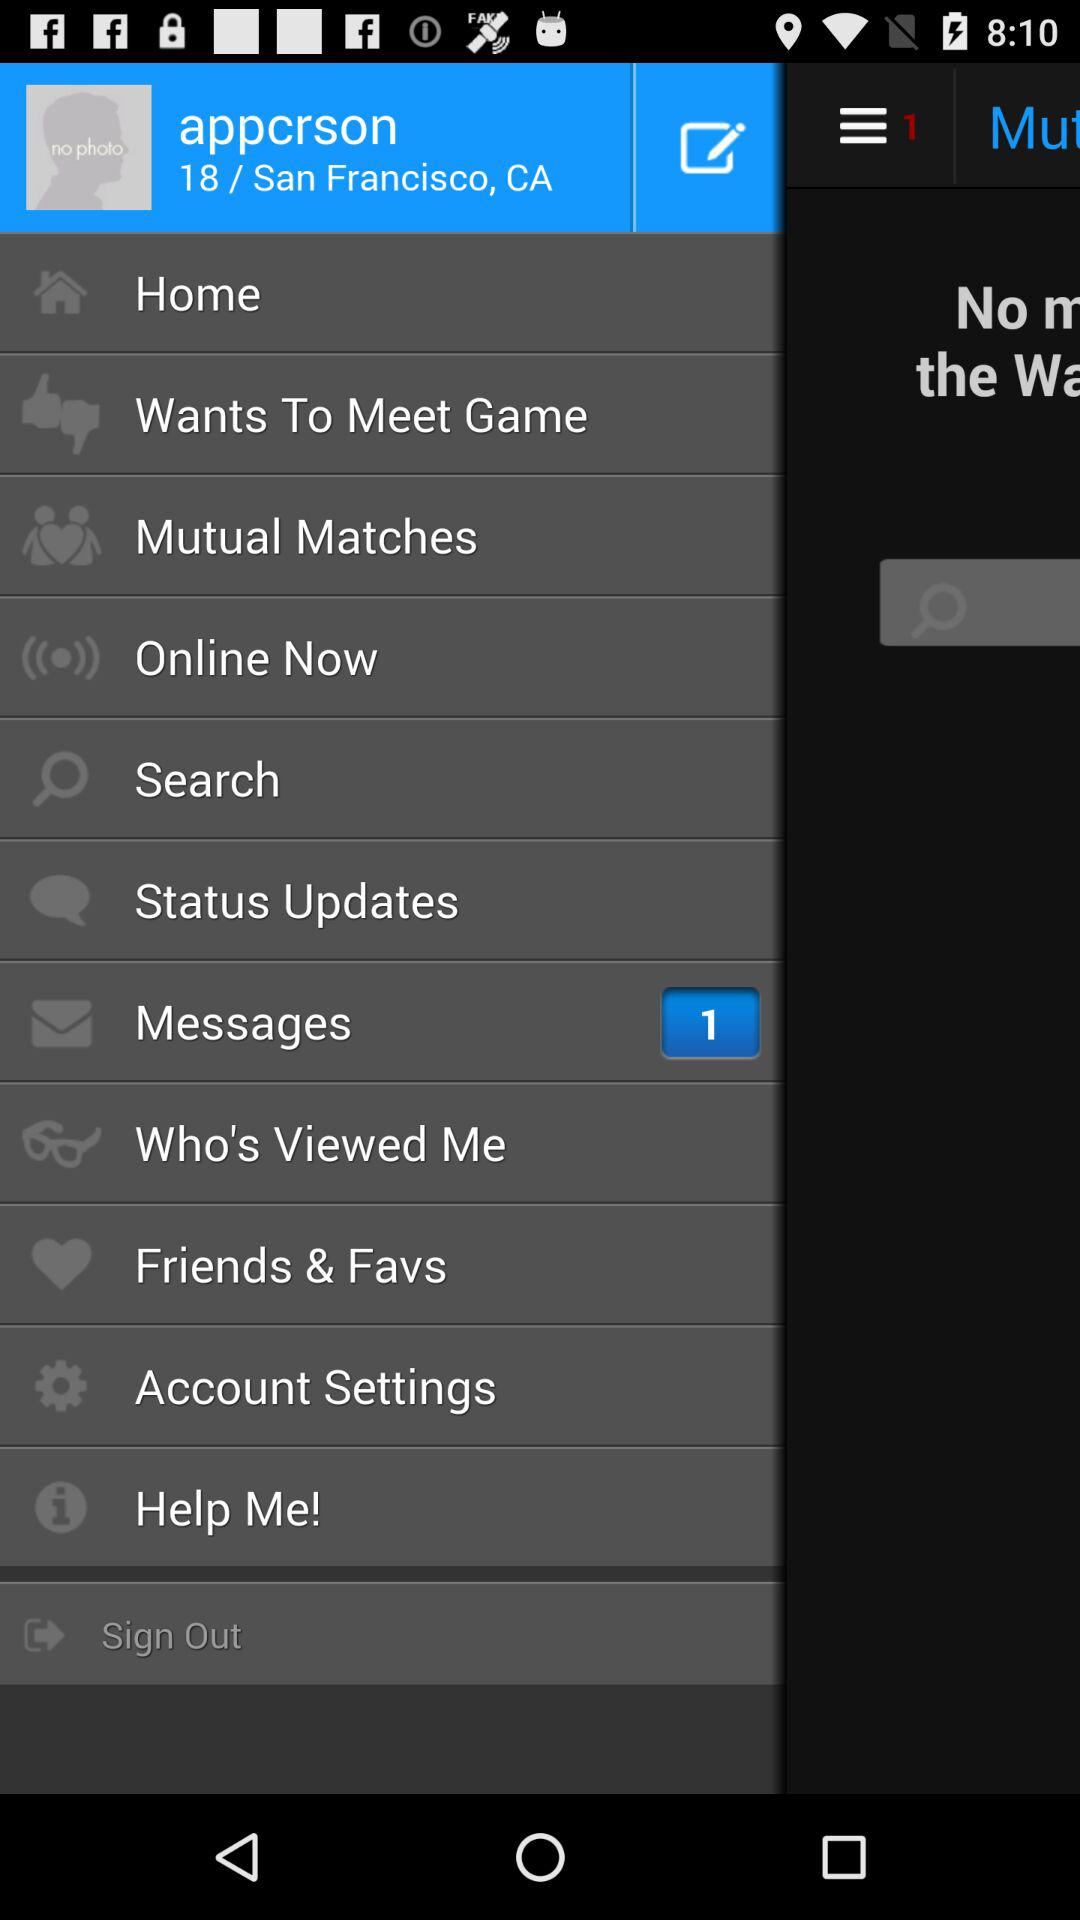How many unread messages are there? There is 1 unread message. 